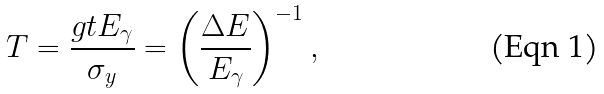<formula> <loc_0><loc_0><loc_500><loc_500>T = \frac { g t E _ { \gamma } } { \sigma _ { y } } = \left ( \frac { \Delta E } { E _ { \gamma } } \right ) ^ { - 1 } ,</formula> 